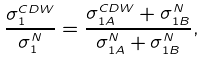Convert formula to latex. <formula><loc_0><loc_0><loc_500><loc_500>\frac { \sigma _ { 1 } ^ { C D W } } { \sigma _ { 1 } ^ { N } } = \frac { \sigma _ { 1 A } ^ { C D W } + \sigma _ { 1 B } ^ { N } } { \sigma _ { 1 A } ^ { N } + \sigma _ { 1 B } ^ { N } } ,</formula> 